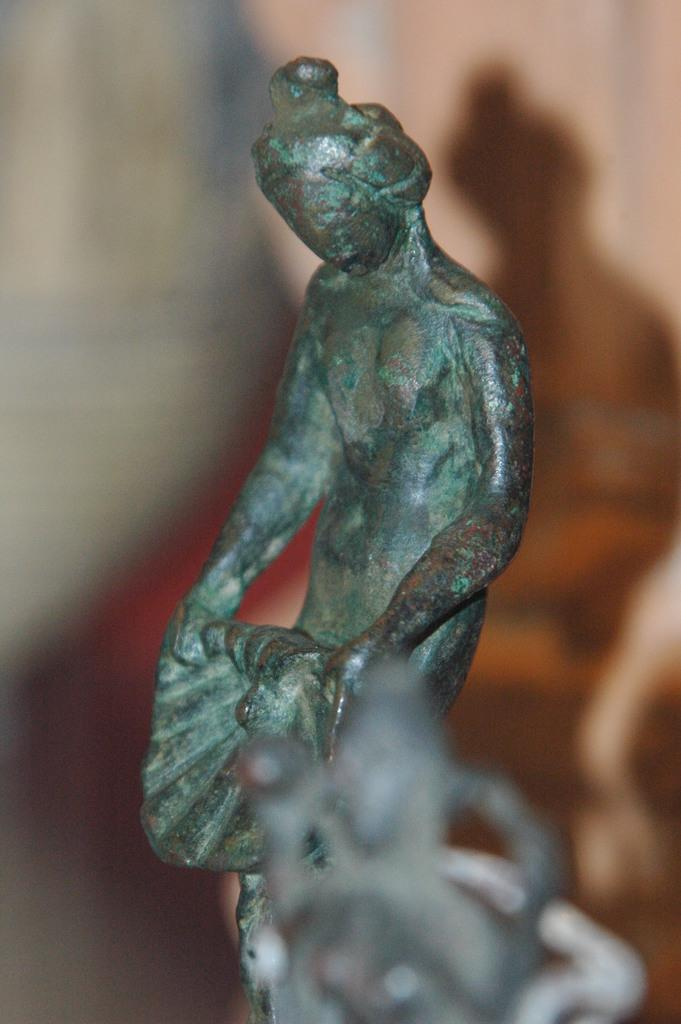What is the main subject in the foreground of the image? There is a blurred object in the foreground of the image. What can be seen in the middle of the image? There is a green-colored sculpture in the middle of the image. What type of learning can be observed in the image? There is no learning activity depicted in the image; it features a blurred object in the foreground and a green-colored sculpture in the middle. Is there a flame present in the image? No, there is no flame present in the image. 